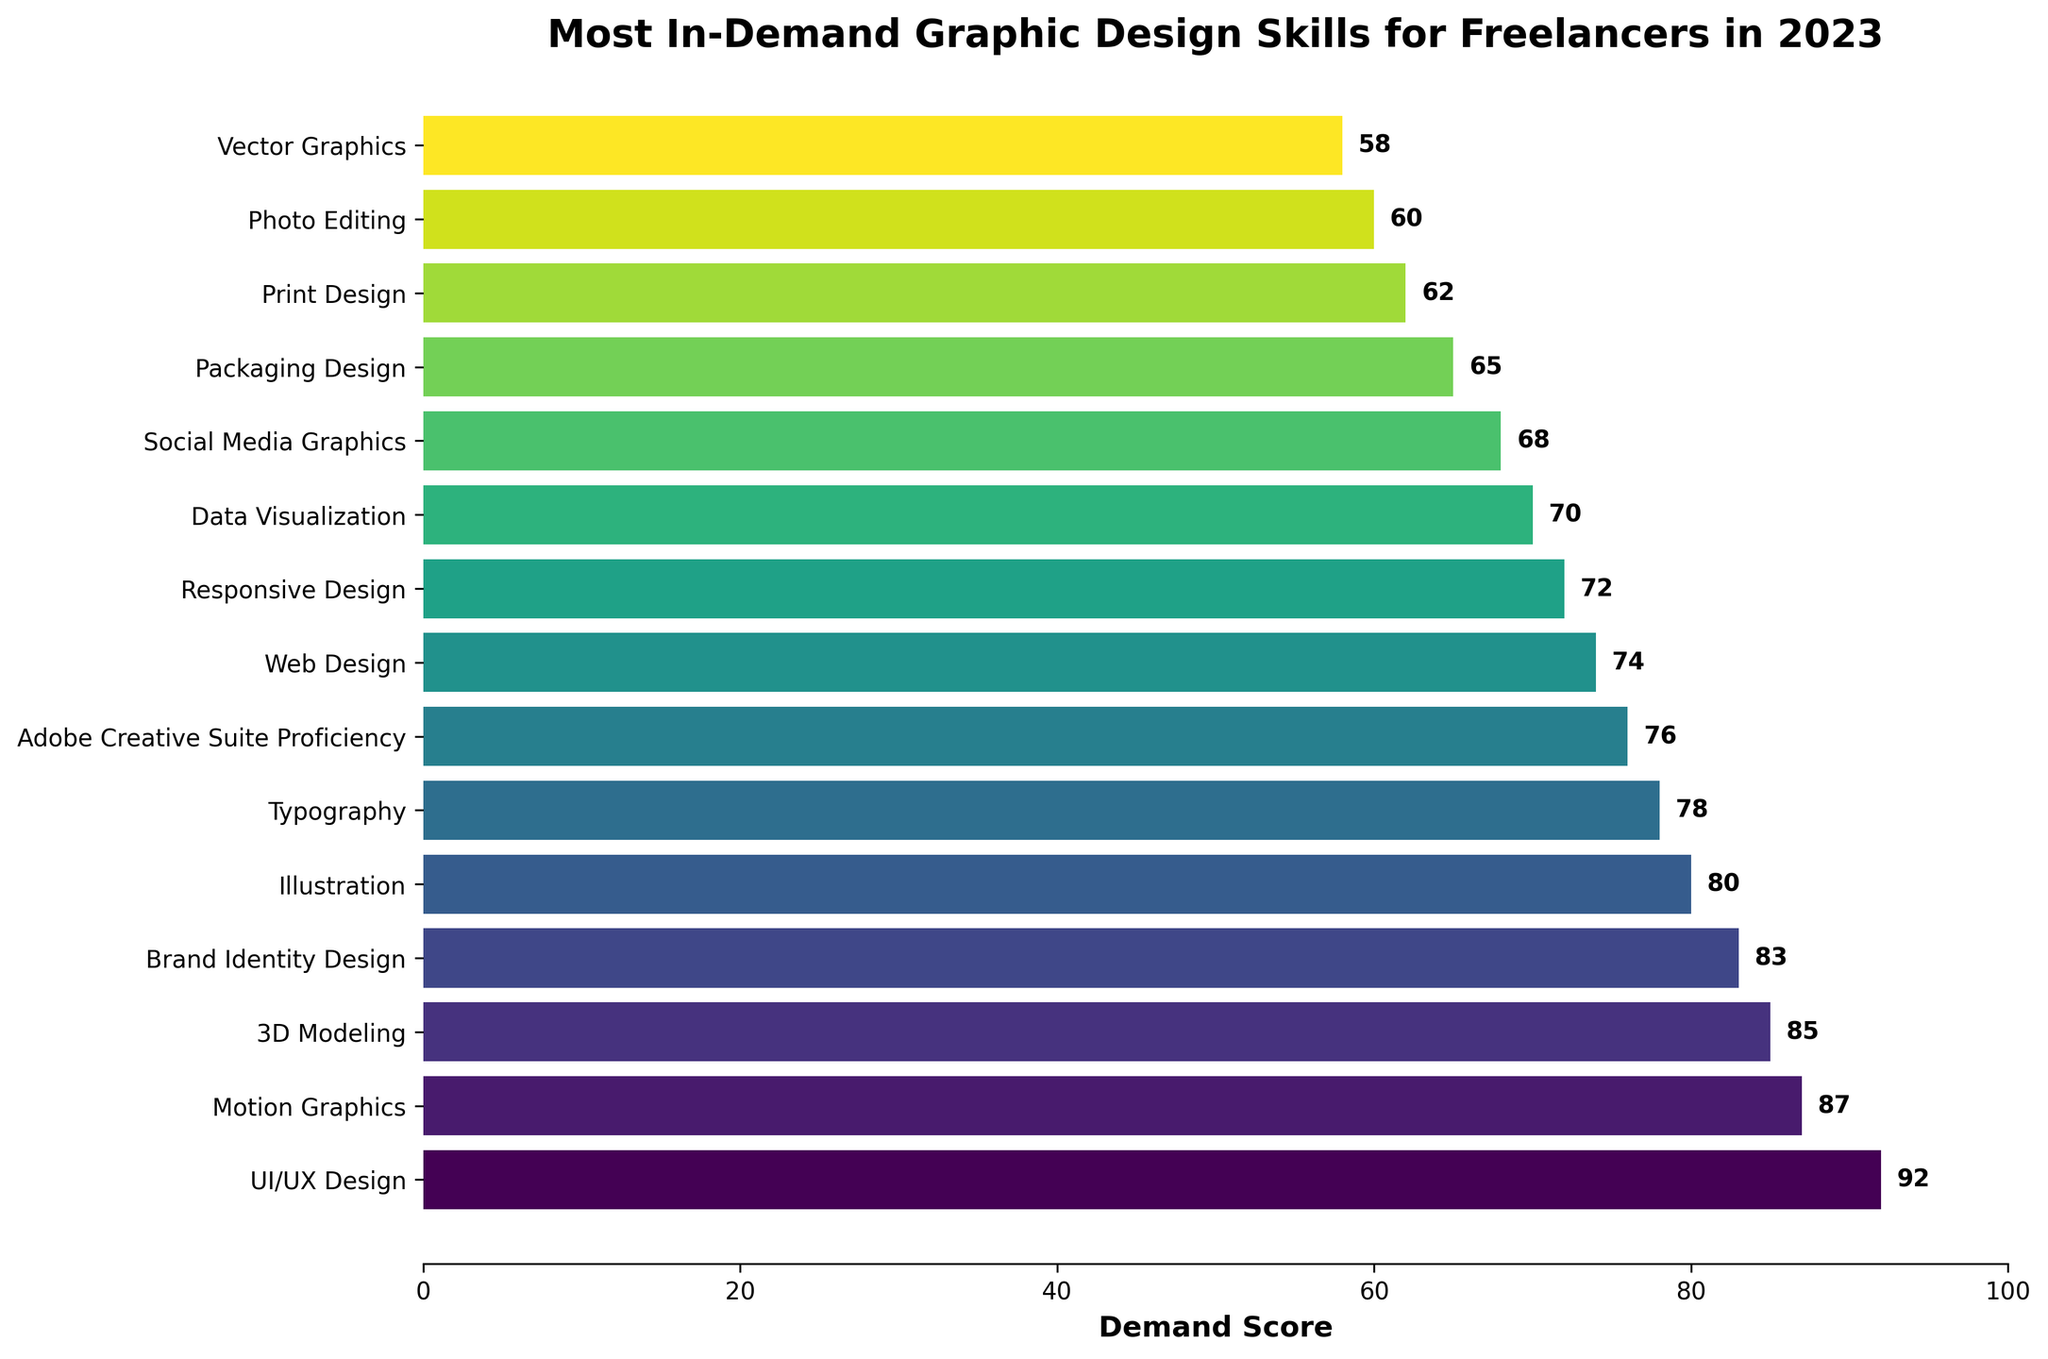Which skill has the highest demand score? The chart shows the bars representing the demand scores for each skill. The longest bar corresponds to UI/UX Design with a demand score of 92.
Answer: UI/UX Design What is the difference in demand score between Motion Graphics and 3D Modeling? According to the chart, Motion Graphics has a demand score of 87 and 3D Modeling has a demand score of 85. Subtracting the two scores, 87 - 85 = 2.
Answer: 2 Which skill falls at the midpoint of the demand score range? To find the midpoint, look for the skill that appears centrally among all listed skills in the chart. With a total of 15 skills, the 8th skill from either end is Web Design, with a demand score of 74.
Answer: Web Design Are Social Media Graphics and Packaging Design equally in demand? The demand scores for Social Media Graphics and Packaging Design are shown as 68 and 65, respectively. The scores are not equal.
Answer: No What is the average demand score of the top 3 most in-demand skills? The top three skills are UI/UX Design (92), Motion Graphics (87), and 3D Modeling (85). The average is calculated as (92 + 87 + 85) / 3 = 264 / 3 = 88.
Answer: 88 Which skill has a higher demand score: Data Visualization or Typography? The chart shows Data Visualization with a demand score of 70 and Typography with a demand score of 78. Therefore, Typography has a higher score.
Answer: Typography How many skills have a demand score lower than 70? By visual inspection, the skills with demand scores lower than 70 are Social Media Graphics (68), Packaging Design (65), Print Design (62), Photo Editing (60), and Vector Graphics (58), making a total of 5 skills.
Answer: 5 What is the combined demand score of the least in-demand skill and the most in-demand skill? The least in-demand skill is Vector Graphics with a score of 58, and the most in-demand skill is UI/UX Design with a score of 92. Combined, they add up to 58 + 92 = 150.
Answer: 150 If the score for Print Design increased by 10%, what would its new score be? The original score for Print Design is 62. Increasing this by 10%: 62 + (0.10 * 62) = 62 + 6.2 = 68.2.
Answer: 68.2 